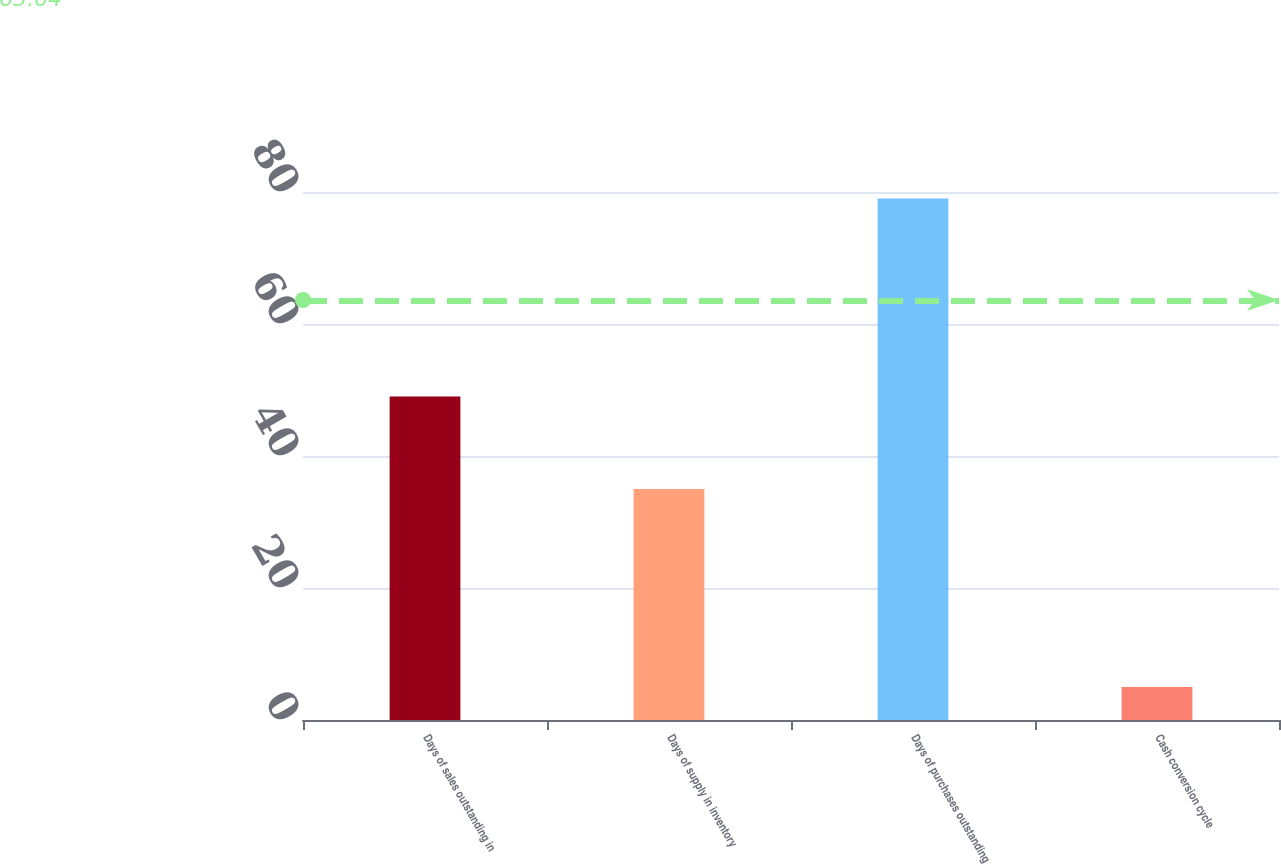<chart> <loc_0><loc_0><loc_500><loc_500><bar_chart><fcel>Days of sales outstanding in<fcel>Days of supply in inventory<fcel>Days of purchases outstanding<fcel>Cash conversion cycle<nl><fcel>49<fcel>35<fcel>79<fcel>5<nl></chart> 